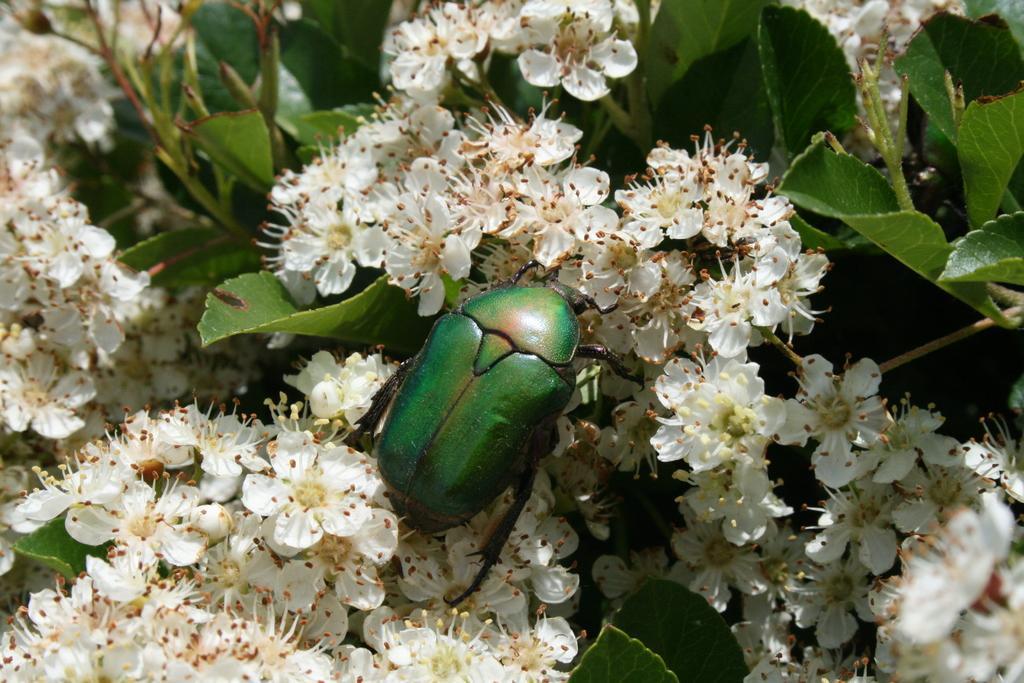Describe this image in one or two sentences. In this image in the center there is an insect, and in the background there are plants and flowers. 